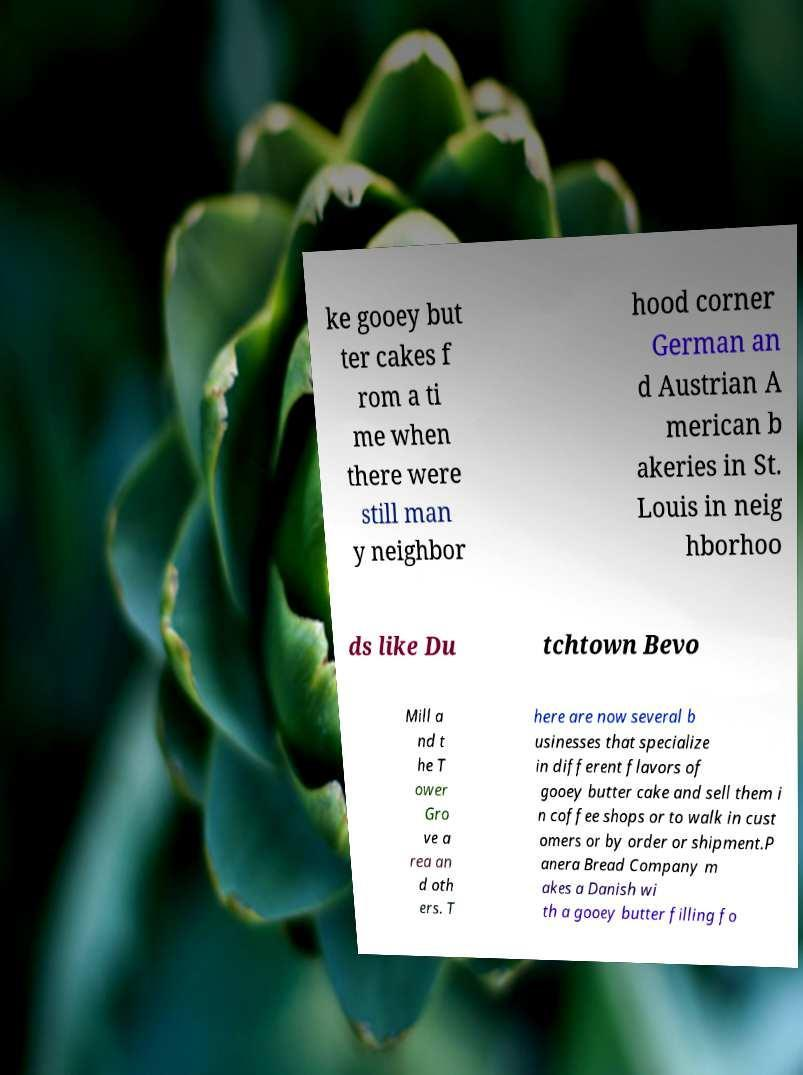I need the written content from this picture converted into text. Can you do that? ke gooey but ter cakes f rom a ti me when there were still man y neighbor hood corner German an d Austrian A merican b akeries in St. Louis in neig hborhoo ds like Du tchtown Bevo Mill a nd t he T ower Gro ve a rea an d oth ers. T here are now several b usinesses that specialize in different flavors of gooey butter cake and sell them i n coffee shops or to walk in cust omers or by order or shipment.P anera Bread Company m akes a Danish wi th a gooey butter filling fo 